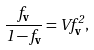<formula> <loc_0><loc_0><loc_500><loc_500>\frac { f _ { \mathbf v } } { 1 - f _ { \mathbf v } } = V f _ { \mathbf v } ^ { 2 } ,</formula> 